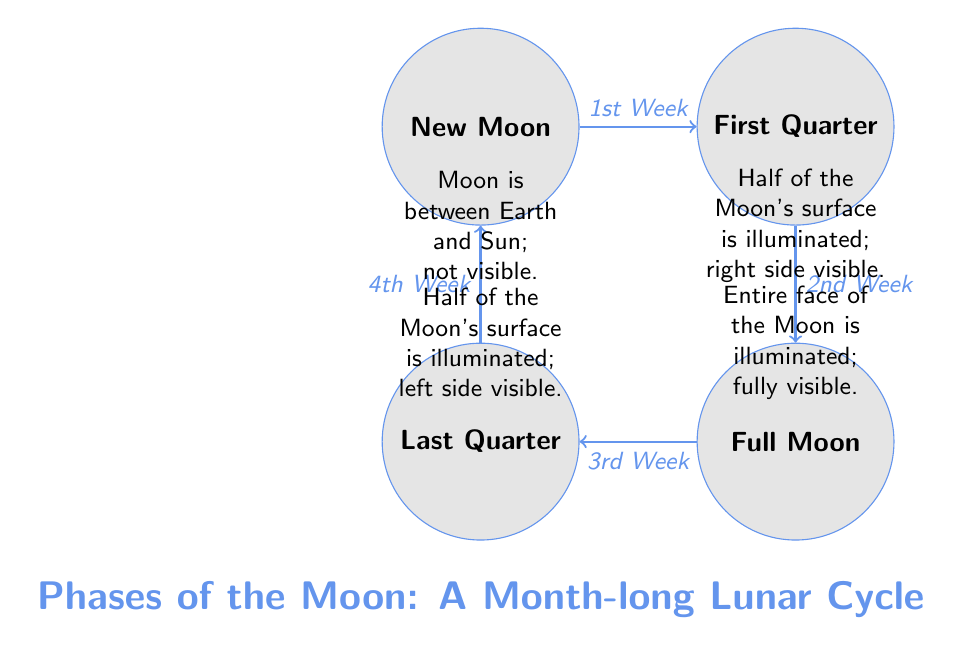What are the four phases of the Moon labeled in the diagram? The diagram clearly labels four phases of the Moon: New Moon, First Quarter, Full Moon, and Last Quarter.
Answer: New Moon, First Quarter, Full Moon, Last Quarter Which phase comes after the First Quarter? According to the direction of the edges in the diagram, after the First Quarter, the next phase is the Full Moon.
Answer: Full Moon What week does the Last Quarter appear in the lunar cycle? The diagram indicates that the Last Quarter phase occurs during the 4th Week as denoted by the edge connecting Last Quarter to New Moon.
Answer: 4th Week How many weeks are represented in the lunar cycle? The diagram illustrates a complete lunar cycle divided into four weeks, each corresponding to a different phase of the Moon.
Answer: Four What is the visibility status of the Moon during the New Moon phase? The diagram notes that during the New Moon phase, the Moon is between Earth and the Sun, making it not visible.
Answer: Not visible Which side of the Moon is visible during the First Quarter? The diagram specifies that during the First Quarter phase, the right side of the Moon is illuminated and visible.
Answer: Right side What relationship exists between the New Moon and the Last Quarter phases? The diagram shows a cyclical relationship connecting the New Moon and Last Quarter phases through their respective weeks, indicating the progression of the lunar cycle.
Answer: Cyclical relationship What color represents the Moon in this diagram? The Moon is drawn in a light gray shade, which is labeled as moongray in the code of the diagram.
Answer: Moongray 